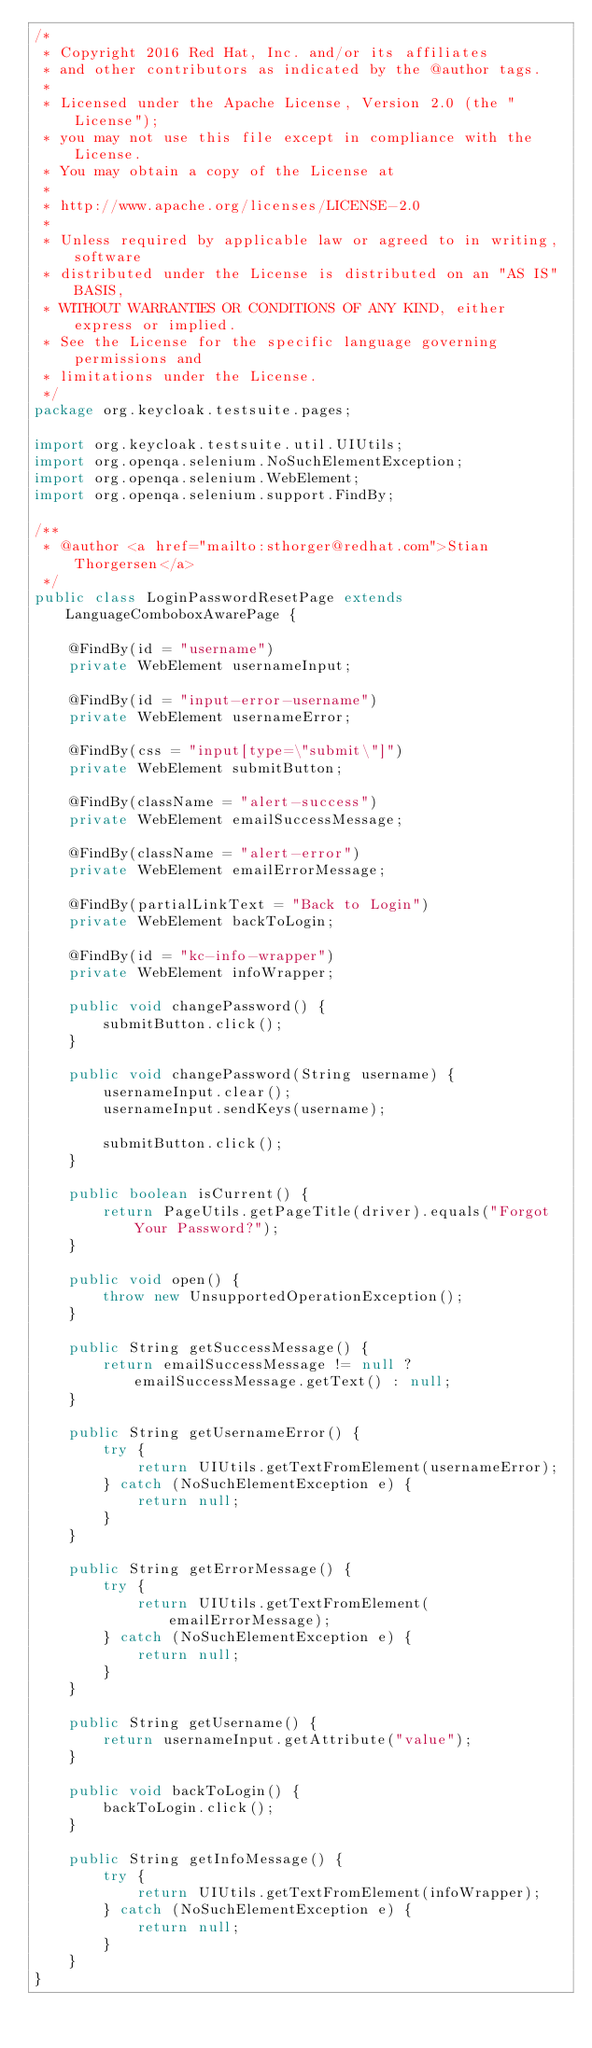<code> <loc_0><loc_0><loc_500><loc_500><_Java_>/*
 * Copyright 2016 Red Hat, Inc. and/or its affiliates
 * and other contributors as indicated by the @author tags.
 *
 * Licensed under the Apache License, Version 2.0 (the "License");
 * you may not use this file except in compliance with the License.
 * You may obtain a copy of the License at
 *
 * http://www.apache.org/licenses/LICENSE-2.0
 *
 * Unless required by applicable law or agreed to in writing, software
 * distributed under the License is distributed on an "AS IS" BASIS,
 * WITHOUT WARRANTIES OR CONDITIONS OF ANY KIND, either express or implied.
 * See the License for the specific language governing permissions and
 * limitations under the License.
 */
package org.keycloak.testsuite.pages;

import org.keycloak.testsuite.util.UIUtils;
import org.openqa.selenium.NoSuchElementException;
import org.openqa.selenium.WebElement;
import org.openqa.selenium.support.FindBy;

/**
 * @author <a href="mailto:sthorger@redhat.com">Stian Thorgersen</a>
 */
public class LoginPasswordResetPage extends LanguageComboboxAwarePage {

    @FindBy(id = "username")
    private WebElement usernameInput;

    @FindBy(id = "input-error-username")
    private WebElement usernameError;

    @FindBy(css = "input[type=\"submit\"]")
    private WebElement submitButton;

    @FindBy(className = "alert-success")
    private WebElement emailSuccessMessage;

    @FindBy(className = "alert-error")
    private WebElement emailErrorMessage;

    @FindBy(partialLinkText = "Back to Login")
    private WebElement backToLogin;

    @FindBy(id = "kc-info-wrapper")
    private WebElement infoWrapper;

    public void changePassword() {
        submitButton.click();
    }

    public void changePassword(String username) {
        usernameInput.clear();
        usernameInput.sendKeys(username);

        submitButton.click();
    }

    public boolean isCurrent() {
        return PageUtils.getPageTitle(driver).equals("Forgot Your Password?");
    }

    public void open() {
        throw new UnsupportedOperationException();
    }

    public String getSuccessMessage() {
        return emailSuccessMessage != null ? emailSuccessMessage.getText() : null;
    }

    public String getUsernameError() {
        try {
            return UIUtils.getTextFromElement(usernameError);
        } catch (NoSuchElementException e) {
            return null;
        }
    }

    public String getErrorMessage() {
        try {
            return UIUtils.getTextFromElement(emailErrorMessage);
        } catch (NoSuchElementException e) {
            return null;
        }
    }

    public String getUsername() {
        return usernameInput.getAttribute("value");
    }

    public void backToLogin() {
        backToLogin.click();
    }

    public String getInfoMessage() {
        try {
            return UIUtils.getTextFromElement(infoWrapper);
        } catch (NoSuchElementException e) {
            return null;
        }
    }
}
</code> 